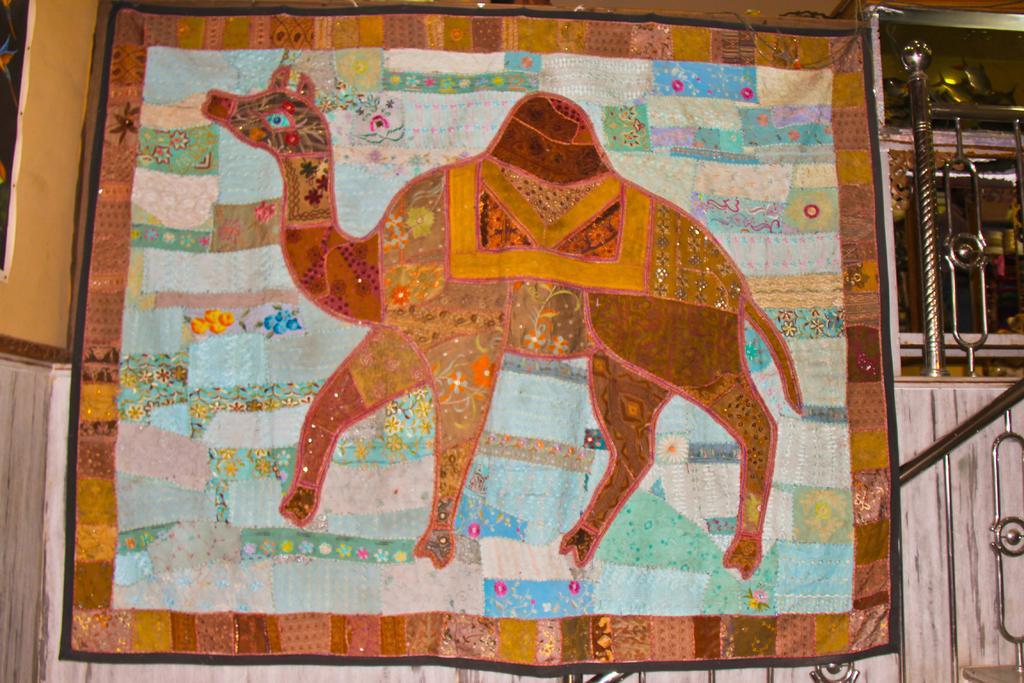Could you give a brief overview of what you see in this image? In this image we can see a banner, on the banner we can see an animal, also we can see the railing, rods, wall and the glass 